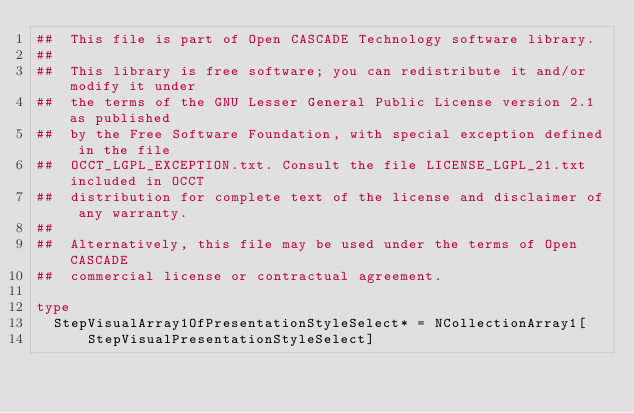Convert code to text. <code><loc_0><loc_0><loc_500><loc_500><_Nim_>##  This file is part of Open CASCADE Technology software library.
##
##  This library is free software; you can redistribute it and/or modify it under
##  the terms of the GNU Lesser General Public License version 2.1 as published
##  by the Free Software Foundation, with special exception defined in the file
##  OCCT_LGPL_EXCEPTION.txt. Consult the file LICENSE_LGPL_21.txt included in OCCT
##  distribution for complete text of the license and disclaimer of any warranty.
##
##  Alternatively, this file may be used under the terms of Open CASCADE
##  commercial license or contractual agreement.

type
  StepVisualArray1OfPresentationStyleSelect* = NCollectionArray1[
      StepVisualPresentationStyleSelect]
</code> 